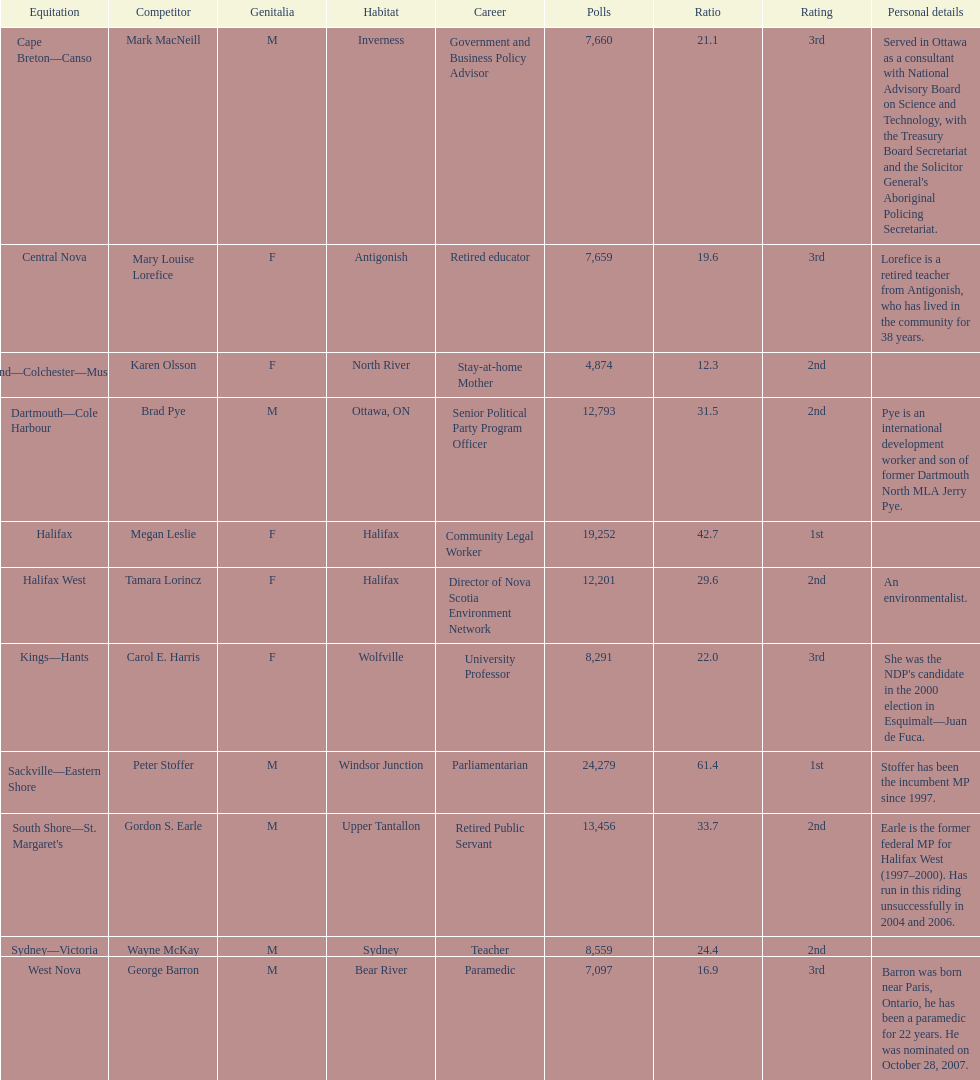Which candidates have the four lowest amount of votes Mark MacNeill, Mary Louise Lorefice, Karen Olsson, George Barron. Out of the following, who has the third most? Mark MacNeill. 